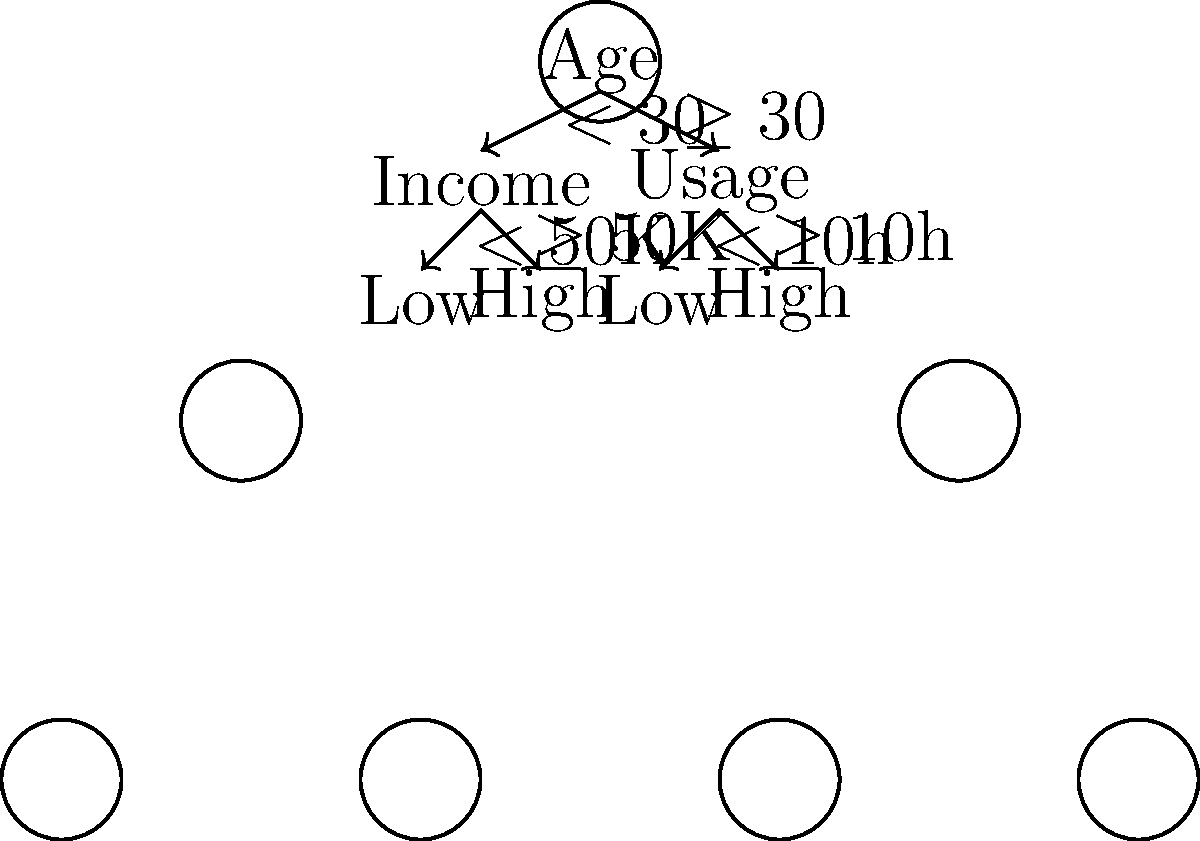Based on the decision tree visualization for the startup's customer segmentation strategy, which segment is likely to have the highest potential for long-term value, and why? To determine the segment with the highest potential for long-term value, let's analyze the decision tree:

1. The root node splits customers based on age: under 30 and 30 or older.

2. For customers under 30:
   a. They are further segmented by income: less than $50K and $50K or more.
   b. Higher income generally indicates more purchasing power and potential for long-term value.

3. For customers 30 or older:
   a. They are segmented by usage: less than 10 hours and 10 hours or more.
   b. Higher usage suggests more engagement with the product, which often correlates with higher long-term value.

4. Comparing the segments:
   a. Young (< 30) with high income (≥ $50K): This group has high purchasing power but may be less stable in their usage patterns.
   b. Older (≥ 30) with high usage (≥ 10h): This group shows high engagement and likely more stable life circumstances.

5. From an investor's perspective, the segment with customers aged 30 or older and high usage (≥ 10h) is likely to have the highest potential for long-term value because:
   a. They demonstrate high engagement with the product.
   b. They are likely to have more stable life and career circumstances.
   c. Their high usage suggests they find significant value in the product, increasing the likelihood of continued use and potential upsells.

Therefore, the segment of customers aged 30 or older with 10 or more hours of usage presents the highest potential for long-term value.
Answer: Customers aged ≥30 with ≥10h usage 